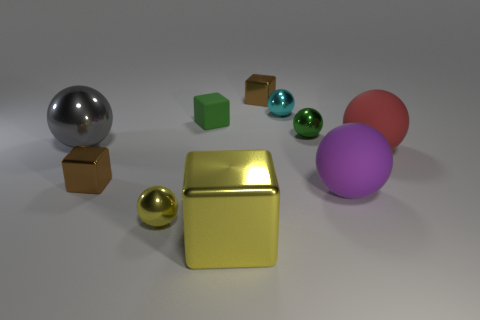How many brown cubes must be subtracted to get 1 brown cubes? 1 Subtract 1 spheres. How many spheres are left? 5 Subtract all gray spheres. How many spheres are left? 5 Subtract all tiny cyan balls. How many balls are left? 5 Subtract all blue balls. Subtract all red cylinders. How many balls are left? 6 Subtract all spheres. How many objects are left? 4 Subtract all green spheres. Subtract all brown things. How many objects are left? 7 Add 3 red objects. How many red objects are left? 4 Add 8 yellow metallic things. How many yellow metallic things exist? 10 Subtract 1 gray spheres. How many objects are left? 9 